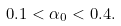<formula> <loc_0><loc_0><loc_500><loc_500>0 . 1 < \alpha _ { 0 } < 0 . 4 .</formula> 